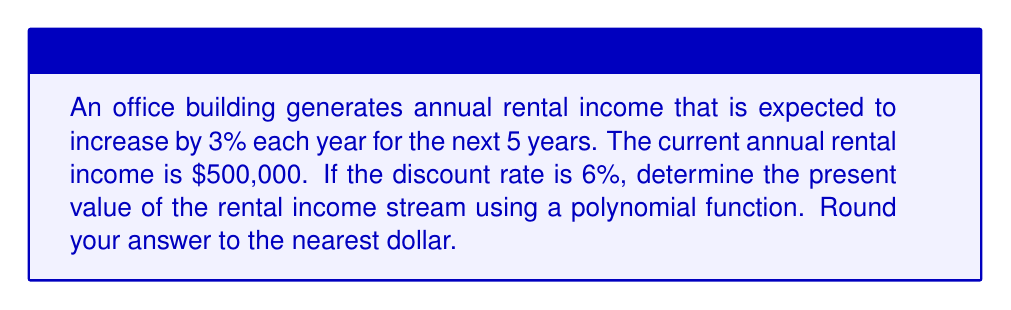Teach me how to tackle this problem. To solve this problem, we'll use the present value formula for a growing annuity, which can be represented as a polynomial function:

$$PV = \frac{CF_1}{(1+r)^1} + \frac{CF_2}{(1+r)^2} + \frac{CF_3}{(1+r)^3} + \frac{CF_4}{(1+r)^4} + \frac{CF_5}{(1+r)^5}$$

Where:
$PV$ = Present Value
$CF_n$ = Cash Flow in year n
$r$ = Discount rate

Step 1: Calculate the cash flows for each year
Year 1: $CF_1 = 500,000 \times (1.03)^1 = 515,000$
Year 2: $CF_2 = 500,000 \times (1.03)^2 = 530,450$
Year 3: $CF_3 = 500,000 \times (1.03)^3 = 546,363.50$
Year 4: $CF_4 = 500,000 \times (1.03)^4 = 562,754.41$
Year 5: $CF_5 = 500,000 \times (1.03)^5 = 579,637.04$

Step 2: Apply the present value formula
$$PV = \frac{515,000}{(1.06)^1} + \frac{530,450}{(1.06)^2} + \frac{546,363.50}{(1.06)^3} + \frac{562,754.41}{(1.06)^4} + \frac{579,637.04}{(1.06)^5}$$

Step 3: Calculate each term
$$PV = 485,849.06 + 471,901.79 + 458,352.76 + 445,194.89 + 432,420.85$$

Step 4: Sum up the terms
$$PV = 2,293,719.35$$

Step 5: Round to the nearest dollar
$$PV = 2,293,719$$
Answer: $2,293,719 